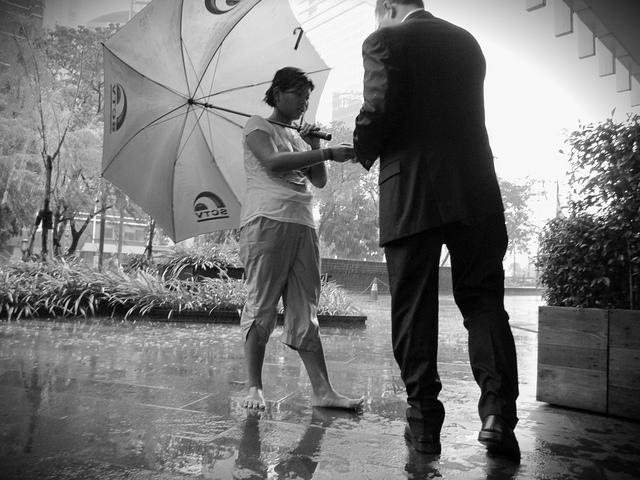What is she giving the man? Please explain your reasoning. change. She's giving change. 